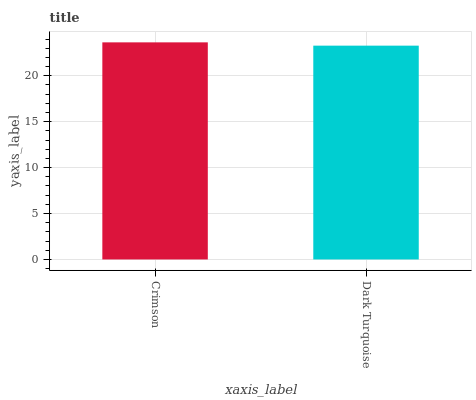Is Dark Turquoise the minimum?
Answer yes or no. Yes. Is Crimson the maximum?
Answer yes or no. Yes. Is Dark Turquoise the maximum?
Answer yes or no. No. Is Crimson greater than Dark Turquoise?
Answer yes or no. Yes. Is Dark Turquoise less than Crimson?
Answer yes or no. Yes. Is Dark Turquoise greater than Crimson?
Answer yes or no. No. Is Crimson less than Dark Turquoise?
Answer yes or no. No. Is Crimson the high median?
Answer yes or no. Yes. Is Dark Turquoise the low median?
Answer yes or no. Yes. Is Dark Turquoise the high median?
Answer yes or no. No. Is Crimson the low median?
Answer yes or no. No. 